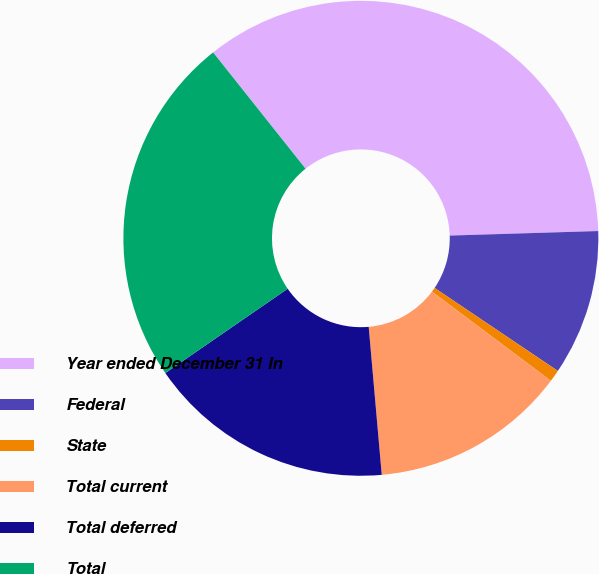Convert chart to OTSL. <chart><loc_0><loc_0><loc_500><loc_500><pie_chart><fcel>Year ended December 31 In<fcel>Federal<fcel>State<fcel>Total current<fcel>Total deferred<fcel>Total<nl><fcel>35.21%<fcel>9.92%<fcel>0.81%<fcel>13.36%<fcel>16.8%<fcel>23.92%<nl></chart> 